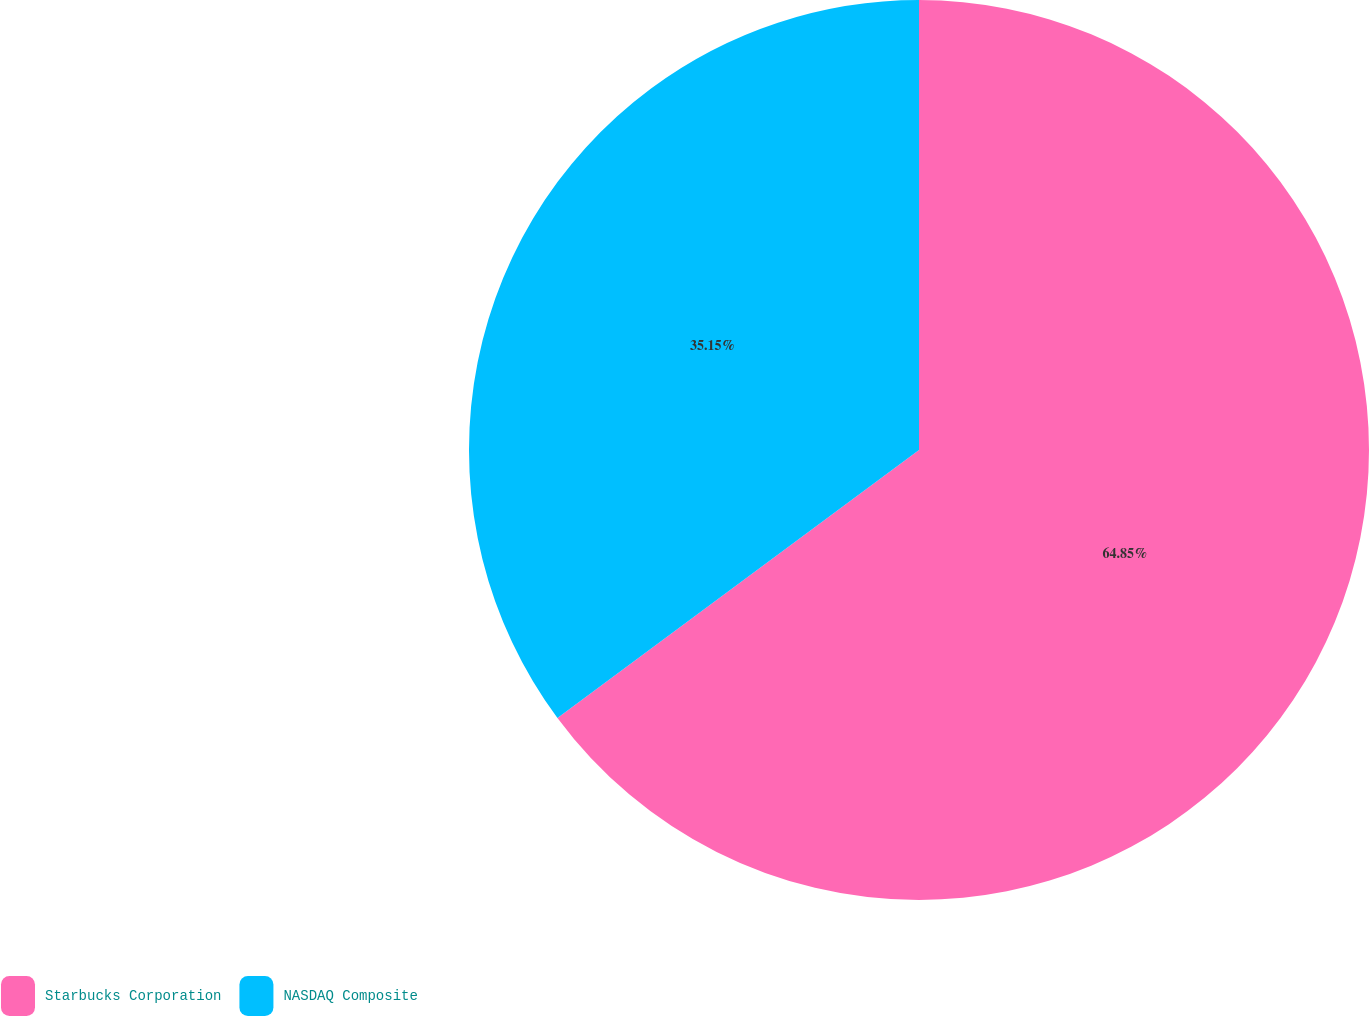Convert chart. <chart><loc_0><loc_0><loc_500><loc_500><pie_chart><fcel>Starbucks Corporation<fcel>NASDAQ Composite<nl><fcel>64.85%<fcel>35.15%<nl></chart> 